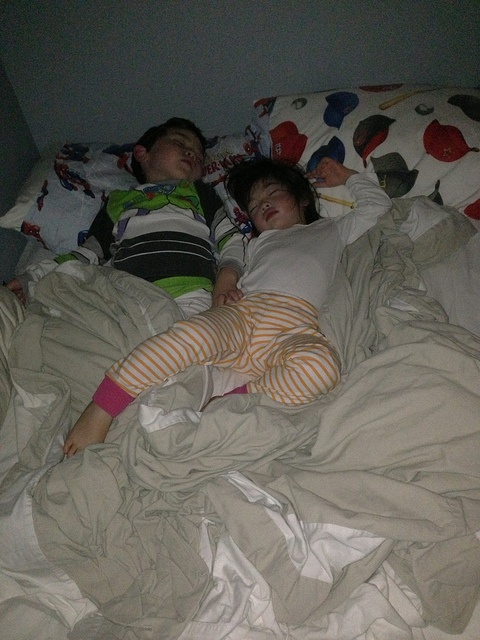Describe the objects in this image and their specific colors. I can see bed in black, gray, and darkgray tones, people in black and gray tones, and people in black, gray, and darkgreen tones in this image. 